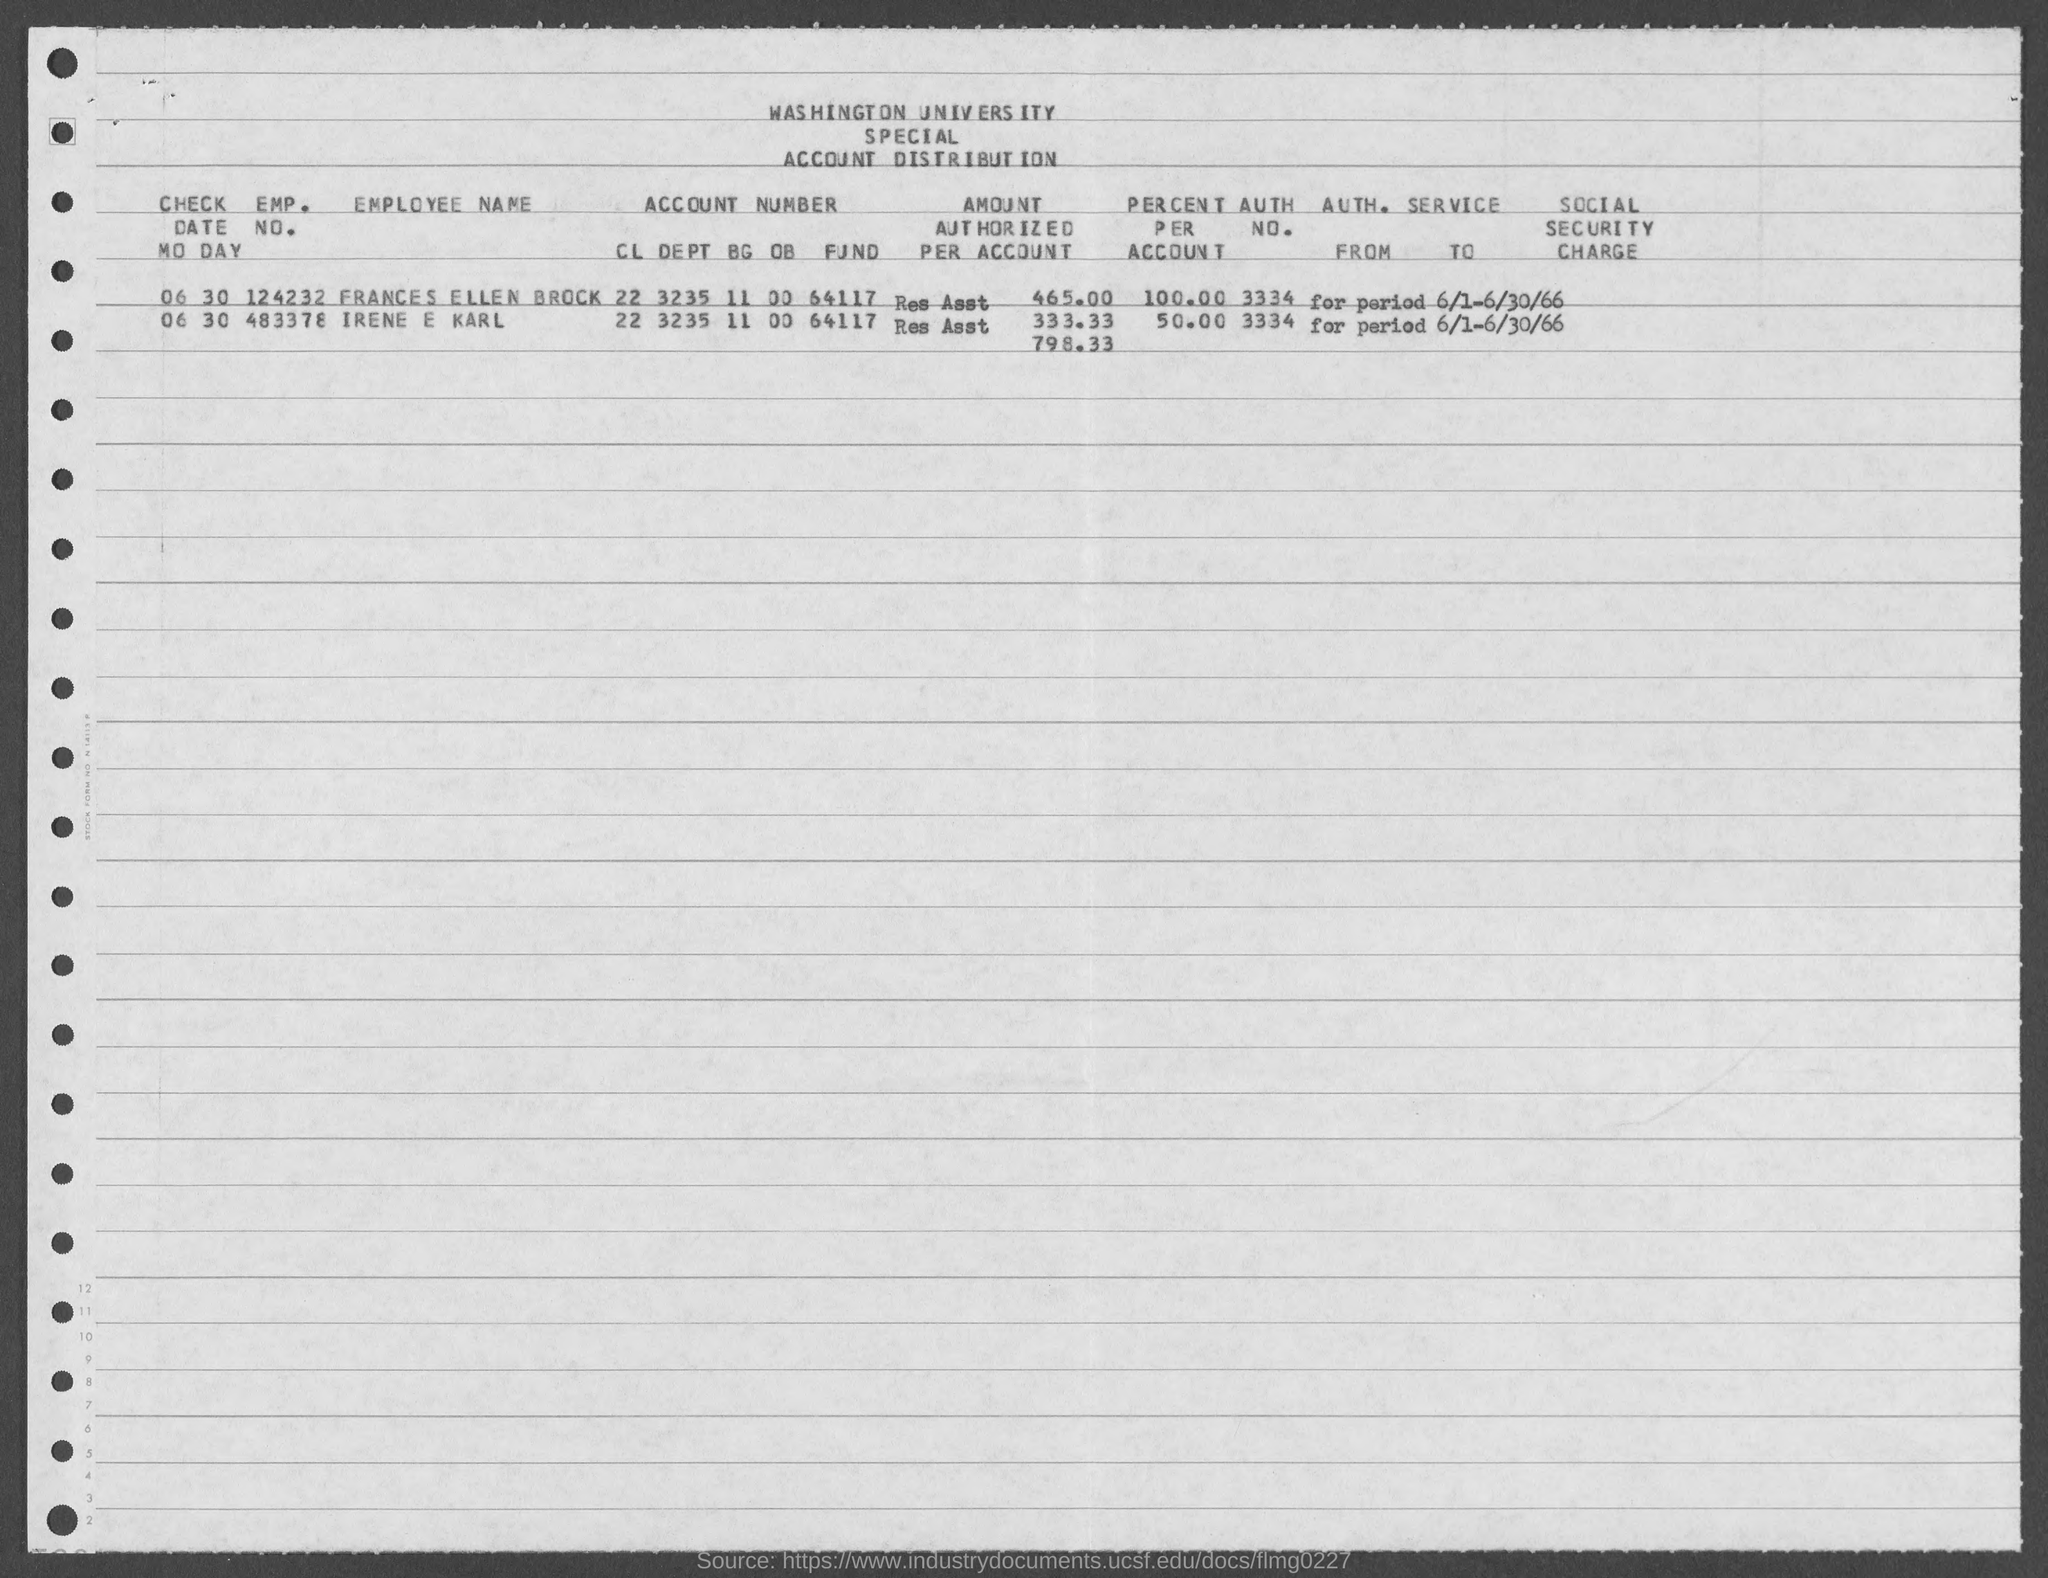Specify some key components in this picture. FRANCES ELLEN BROCK has an employee number of 124232... The person with Employee Number 483378 is Irene E Karl. 